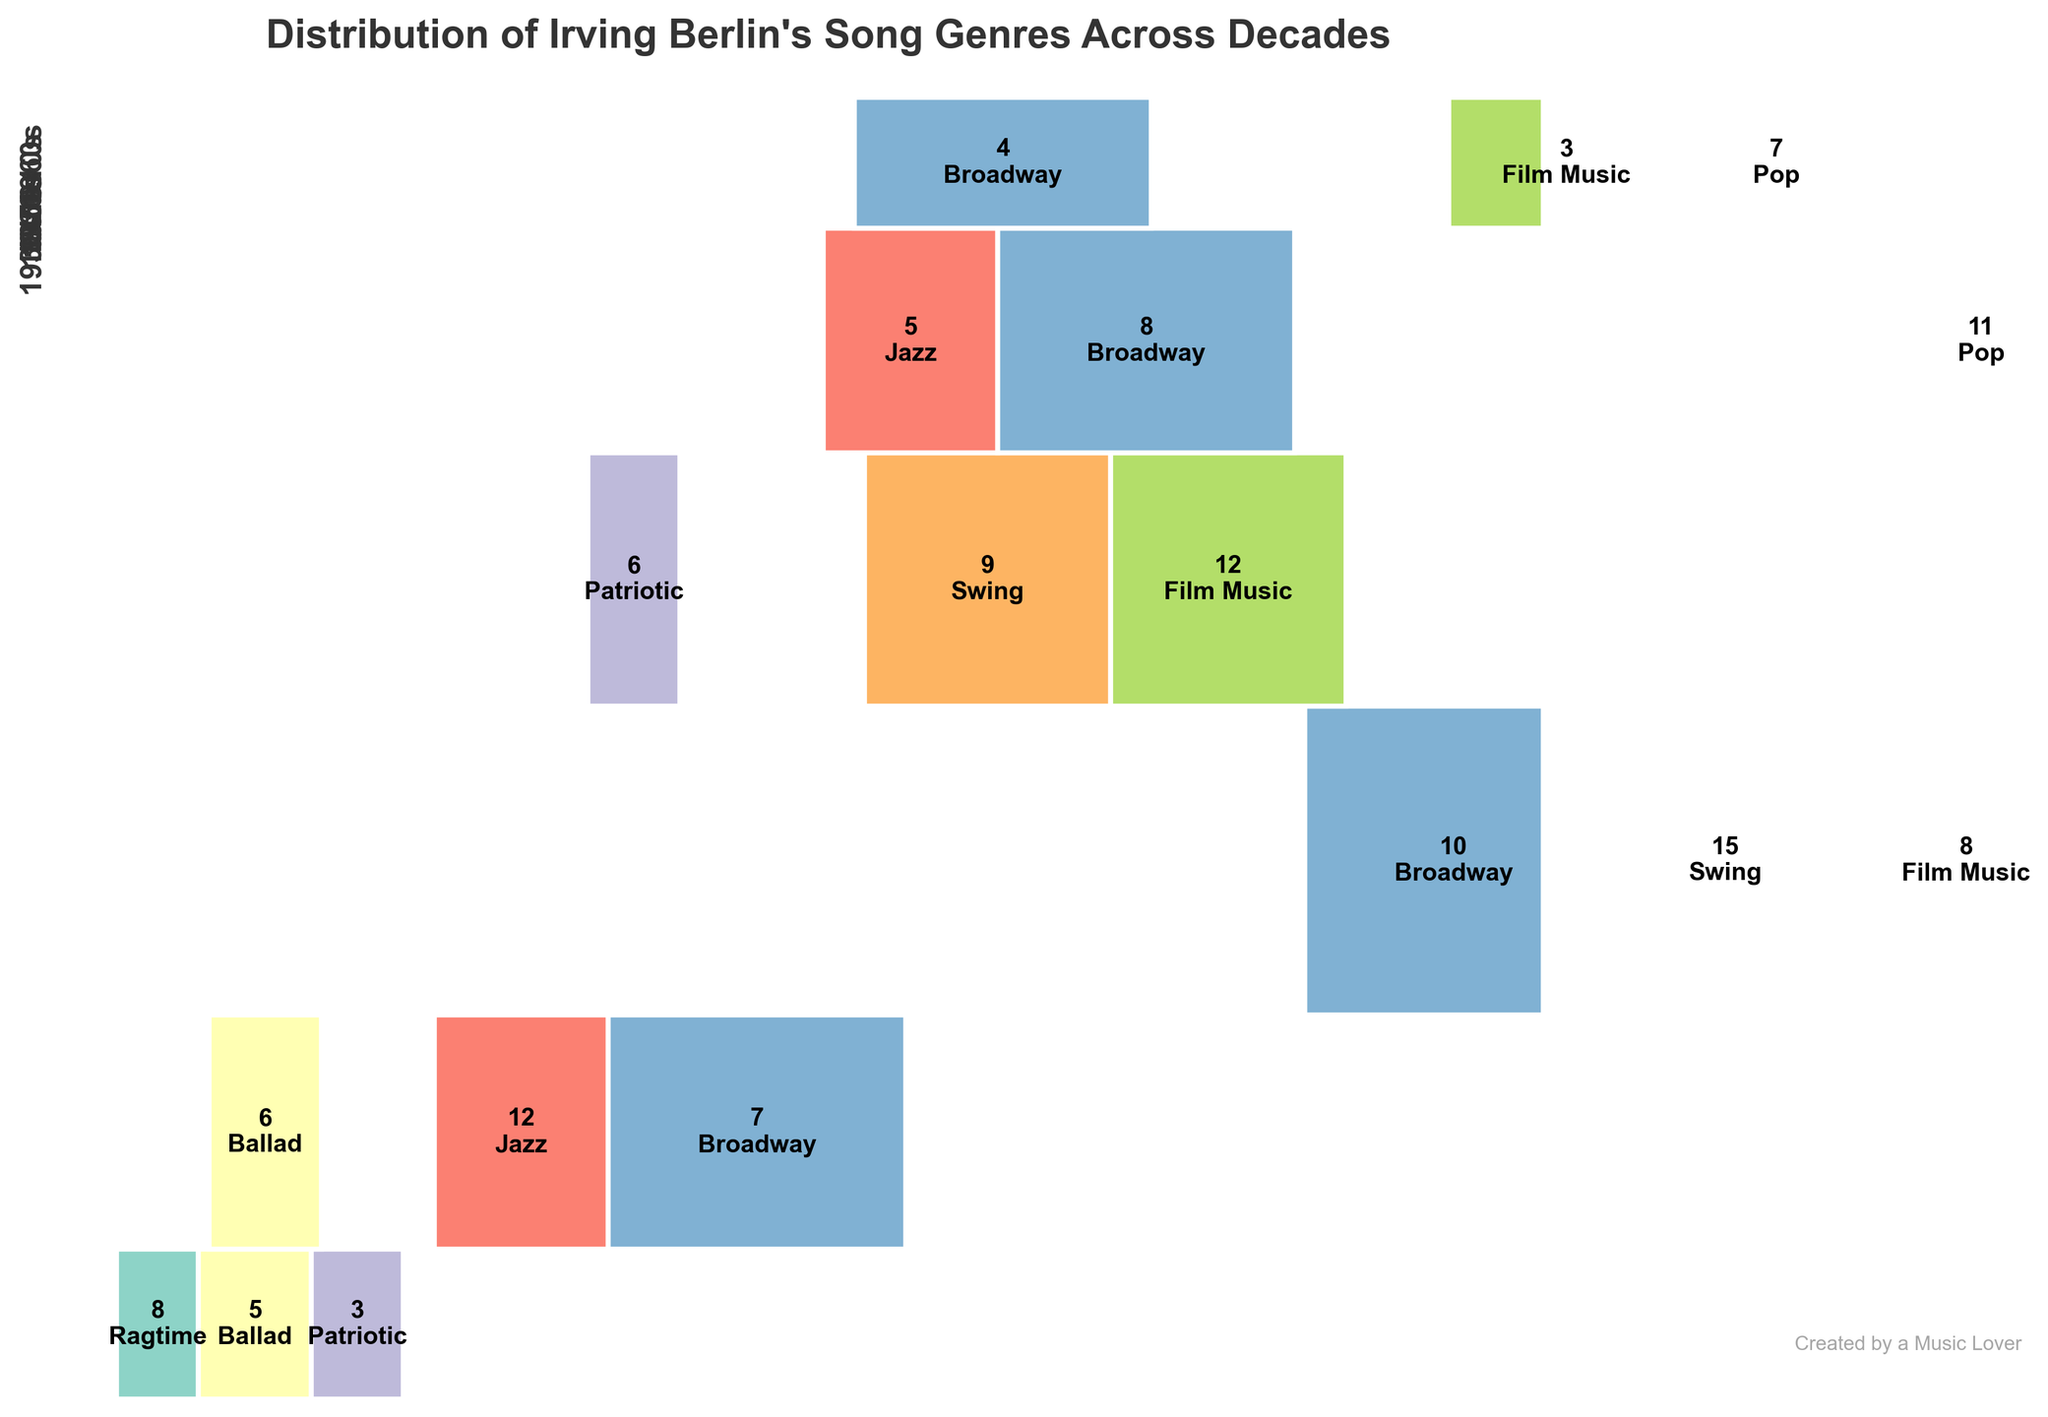What is the title of the Mosaic Plot? The title of the figure is written at the top, which provides a quick understanding of what the plot displays. It says, "Distribution of Irving Berlin's Song Genres Across Decades."
Answer: Distribution of Irving Berlin's Song Genres Across Decades Which decade has the highest number of songs? Observing the Mosaic Plot, we can see that the 1930s occupy the largest vertical space, indicating the highest total count for that decade.
Answer: 1930s How many songs were in the Swing genre in the 1930s? The Swing genre in the 1930s is represented by a specific rectangular segment within that decade's section. The number inside that rectangle indicates there are 15 Swing songs.
Answer: 15 Which genre was most prevalent in the 1920s? In the 1920s section, the largest horizontal rectangle represents the Jazz genre, indicating it had the highest count.
Answer: Jazz Compare the number of Patriotic songs in the 1910s to the 1940s. In the 1910s, the Patriotic genre has a count of 3, while in the 1940s, it has a count of 6. So, there are more Patriotic songs in the 1940s.
Answer: 1940s What proportion of the songs in the 1950s were Pop songs? In the 1950s section, the Pop genre rectangle is labeled with the number 11. The total for the 1950s is calculated by adding up all genres (8+11+5 = 24). The proportion is therefore \( \frac{11}{24} \).
Answer: \( \frac{11}{24} \) How does the number of Ballad songs in the 1920s compare to those in the 1910s? The 1920s section shows 6 Ballad songs, while the 1910s have 5 Ballad songs. There is one more Ballad song in the 1920s than in the 1910s.
Answer: 1 more in 1920s What genre appears in every decade except the 1960s? By examining the figure, we can see that the Broadway genre has rectangular sections in each decade block except the 1960s.
Answer: Broadway Which decade had the highest diversity of genres represented? Looking at the number of different colored rectangles within each decade's block, the 1940s and 1950s each show a variety of different genres, including Patriotic, Film Music, Swing, Pop, Jazz, and Broadway.
Answer: 1940s and 1950s Were there more Jazz songs in the 1920s or the 1950s? The Jazz genre rectangle in the 1920s shows a count of 12, whereas in the 1950s, the count is 5. There were more Jazz songs in the 1920s than the 1950s.
Answer: 1920s 